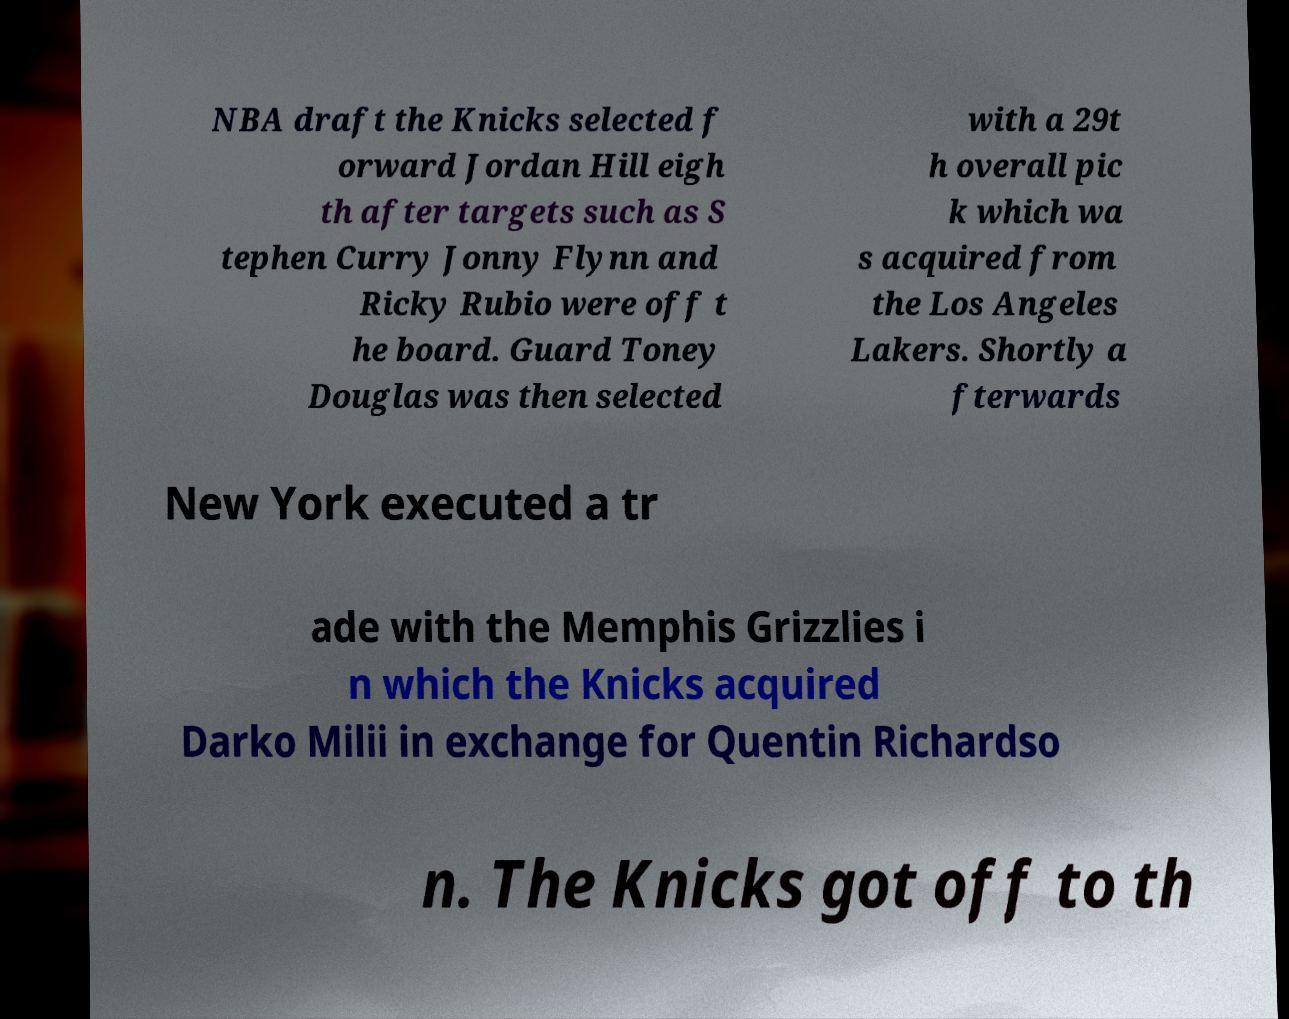There's text embedded in this image that I need extracted. Can you transcribe it verbatim? NBA draft the Knicks selected f orward Jordan Hill eigh th after targets such as S tephen Curry Jonny Flynn and Ricky Rubio were off t he board. Guard Toney Douglas was then selected with a 29t h overall pic k which wa s acquired from the Los Angeles Lakers. Shortly a fterwards New York executed a tr ade with the Memphis Grizzlies i n which the Knicks acquired Darko Milii in exchange for Quentin Richardso n. The Knicks got off to th 